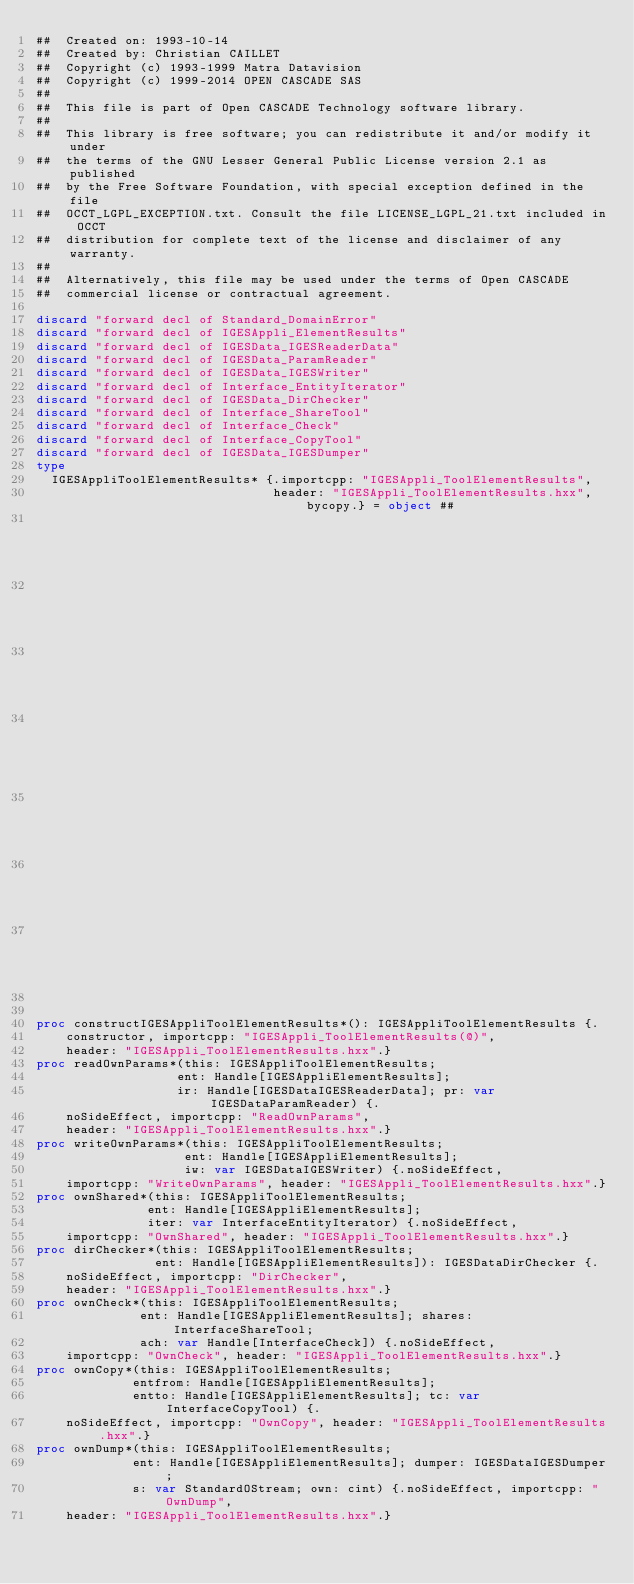<code> <loc_0><loc_0><loc_500><loc_500><_Nim_>##  Created on: 1993-10-14
##  Created by: Christian CAILLET
##  Copyright (c) 1993-1999 Matra Datavision
##  Copyright (c) 1999-2014 OPEN CASCADE SAS
##
##  This file is part of Open CASCADE Technology software library.
##
##  This library is free software; you can redistribute it and/or modify it under
##  the terms of the GNU Lesser General Public License version 2.1 as published
##  by the Free Software Foundation, with special exception defined in the file
##  OCCT_LGPL_EXCEPTION.txt. Consult the file LICENSE_LGPL_21.txt included in OCCT
##  distribution for complete text of the license and disclaimer of any warranty.
##
##  Alternatively, this file may be used under the terms of Open CASCADE
##  commercial license or contractual agreement.

discard "forward decl of Standard_DomainError"
discard "forward decl of IGESAppli_ElementResults"
discard "forward decl of IGESData_IGESReaderData"
discard "forward decl of IGESData_ParamReader"
discard "forward decl of IGESData_IGESWriter"
discard "forward decl of Interface_EntityIterator"
discard "forward decl of IGESData_DirChecker"
discard "forward decl of Interface_ShareTool"
discard "forward decl of Interface_Check"
discard "forward decl of Interface_CopyTool"
discard "forward decl of IGESData_IGESDumper"
type
  IGESAppliToolElementResults* {.importcpp: "IGESAppli_ToolElementResults",
                                header: "IGESAppli_ToolElementResults.hxx", bycopy.} = object ##
                                                                                         ## !
                                                                                         ## Returns
                                                                                         ## a
                                                                                         ## ToolElementResults,
                                                                                         ## ready
                                                                                         ## to
                                                                                         ## work


proc constructIGESAppliToolElementResults*(): IGESAppliToolElementResults {.
    constructor, importcpp: "IGESAppli_ToolElementResults(@)",
    header: "IGESAppli_ToolElementResults.hxx".}
proc readOwnParams*(this: IGESAppliToolElementResults;
                   ent: Handle[IGESAppliElementResults];
                   ir: Handle[IGESDataIGESReaderData]; pr: var IGESDataParamReader) {.
    noSideEffect, importcpp: "ReadOwnParams",
    header: "IGESAppli_ToolElementResults.hxx".}
proc writeOwnParams*(this: IGESAppliToolElementResults;
                    ent: Handle[IGESAppliElementResults];
                    iw: var IGESDataIGESWriter) {.noSideEffect,
    importcpp: "WriteOwnParams", header: "IGESAppli_ToolElementResults.hxx".}
proc ownShared*(this: IGESAppliToolElementResults;
               ent: Handle[IGESAppliElementResults];
               iter: var InterfaceEntityIterator) {.noSideEffect,
    importcpp: "OwnShared", header: "IGESAppli_ToolElementResults.hxx".}
proc dirChecker*(this: IGESAppliToolElementResults;
                ent: Handle[IGESAppliElementResults]): IGESDataDirChecker {.
    noSideEffect, importcpp: "DirChecker",
    header: "IGESAppli_ToolElementResults.hxx".}
proc ownCheck*(this: IGESAppliToolElementResults;
              ent: Handle[IGESAppliElementResults]; shares: InterfaceShareTool;
              ach: var Handle[InterfaceCheck]) {.noSideEffect,
    importcpp: "OwnCheck", header: "IGESAppli_ToolElementResults.hxx".}
proc ownCopy*(this: IGESAppliToolElementResults;
             entfrom: Handle[IGESAppliElementResults];
             entto: Handle[IGESAppliElementResults]; tc: var InterfaceCopyTool) {.
    noSideEffect, importcpp: "OwnCopy", header: "IGESAppli_ToolElementResults.hxx".}
proc ownDump*(this: IGESAppliToolElementResults;
             ent: Handle[IGESAppliElementResults]; dumper: IGESDataIGESDumper;
             s: var StandardOStream; own: cint) {.noSideEffect, importcpp: "OwnDump",
    header: "IGESAppli_ToolElementResults.hxx".}

























</code> 